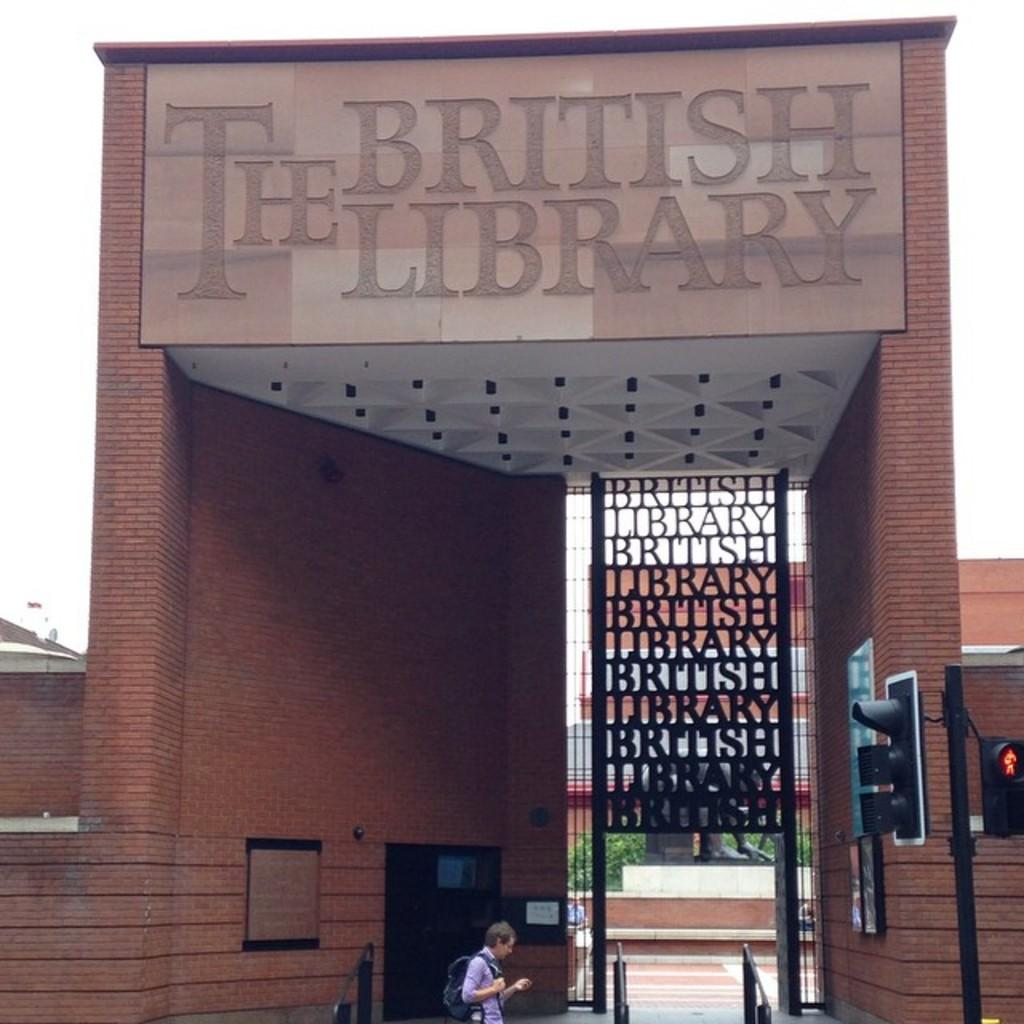What is the name of the building in the image? The building in the image is the British Library. Can you describe the person in front of the building? There is a person in front of the building, but no specific details about their appearance or actions are provided. What is the purpose of the traffic signal in front of the building? The traffic signal in front of the building is used to regulate traffic flow and ensure safety for pedestrians and vehicles. What type of dust can be seen on the stocking of the person in the image? There is no person wearing a stocking in the image, and therefore no dust can be observed on a stocking. 